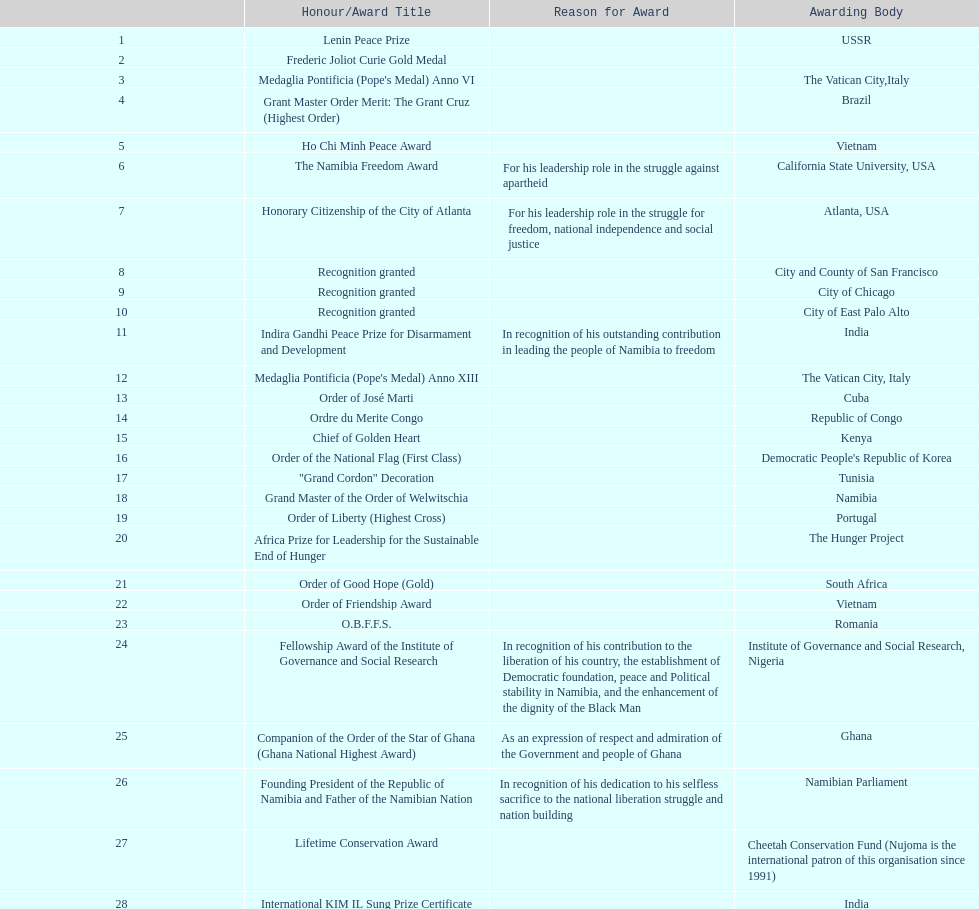Did nujoma win the o.b.f.f.s. award in romania or ghana? Romania. 